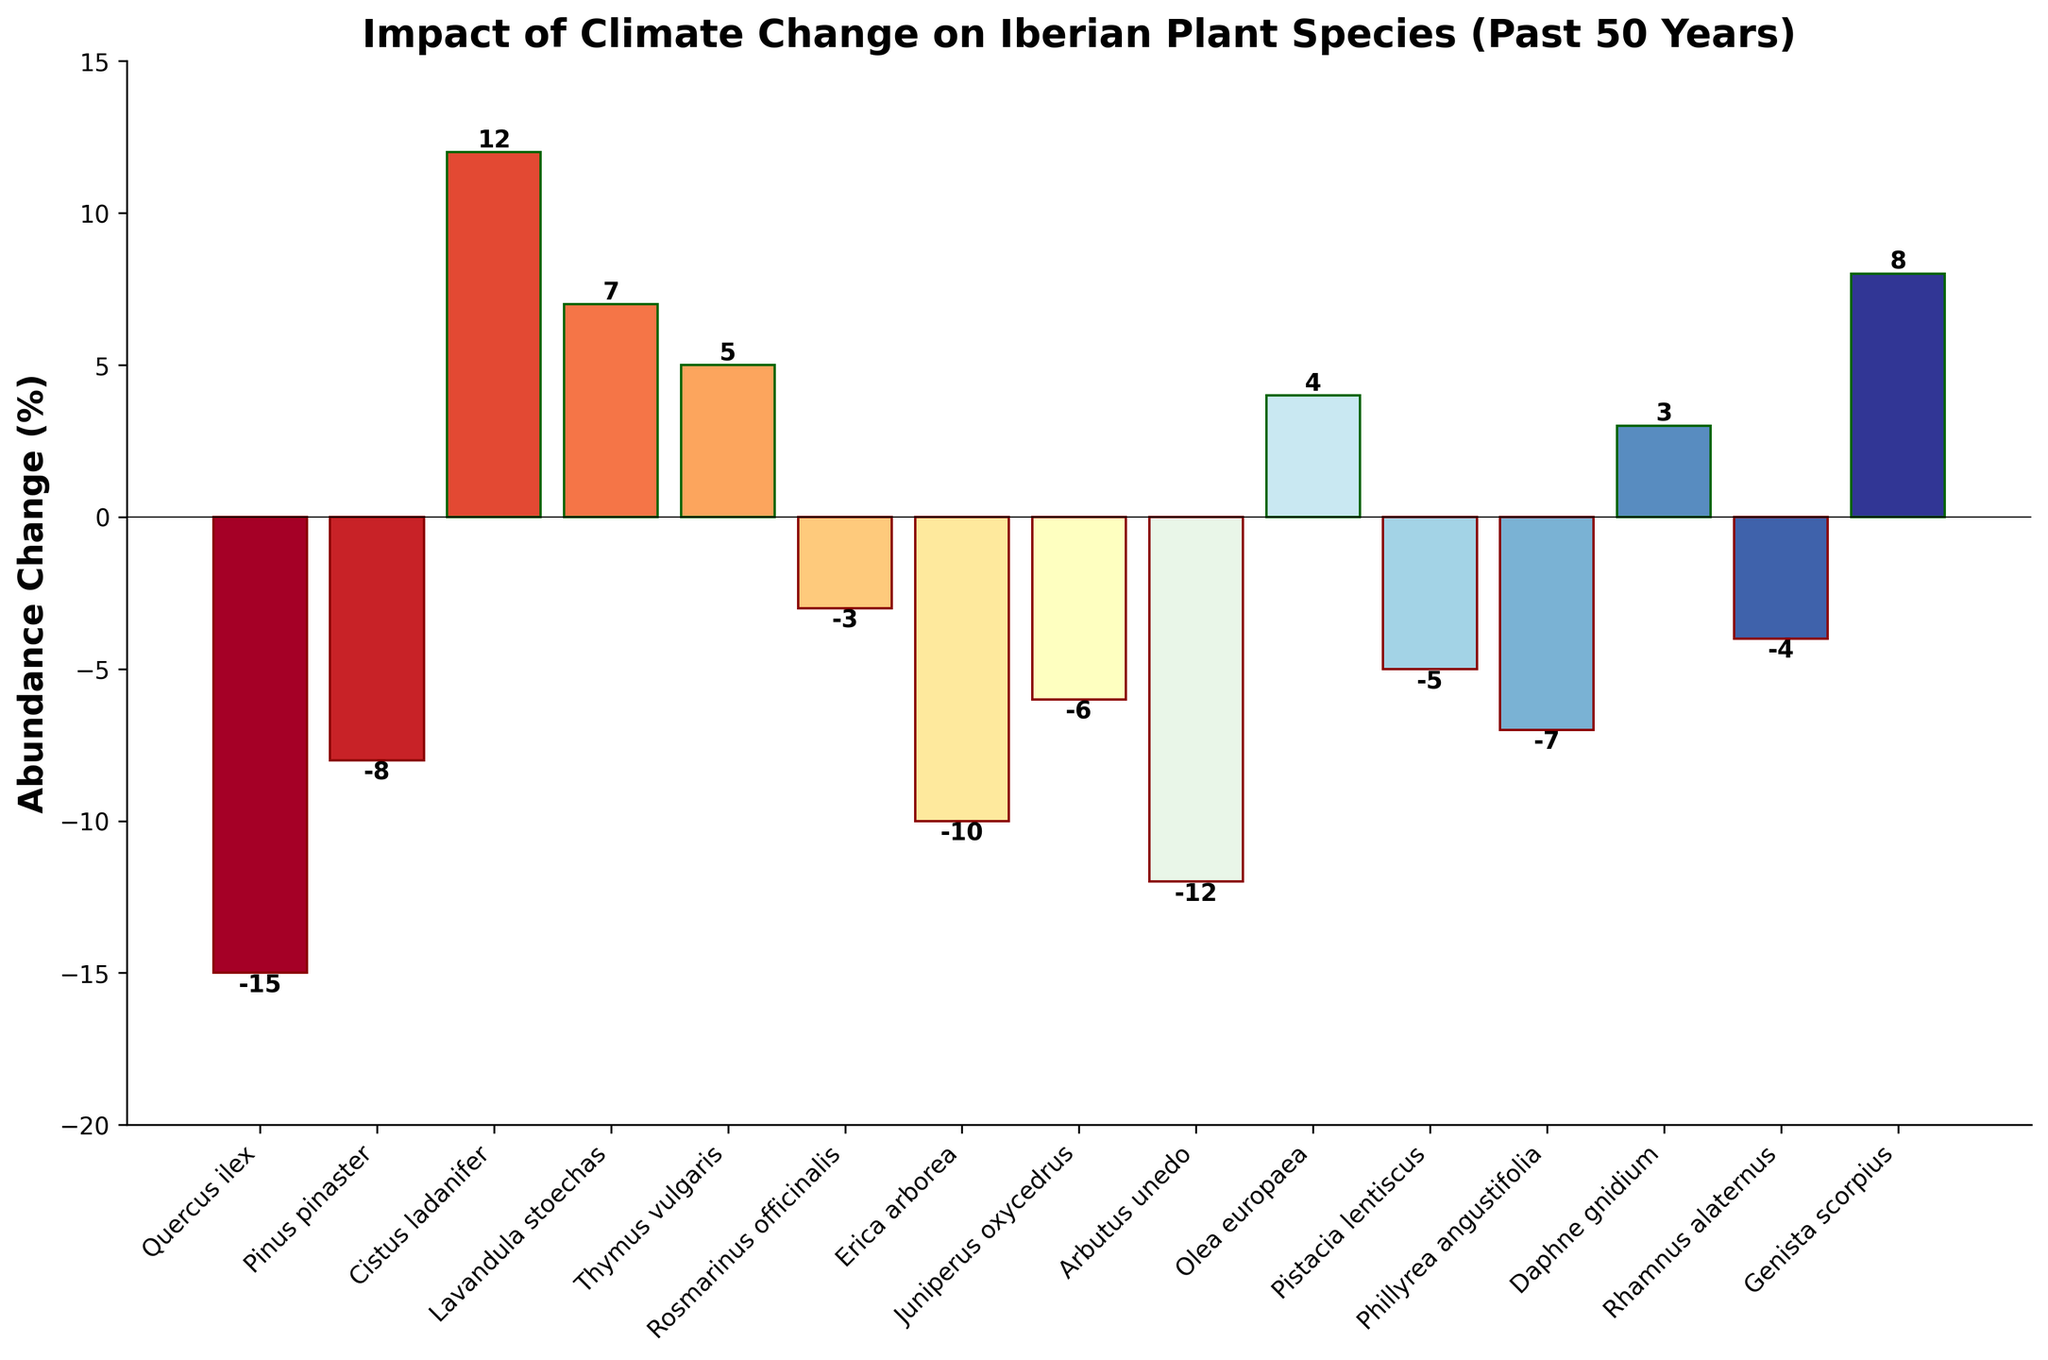What's the range of abundance change percentages for the displayed species? First, identify the maximum and minimum abundance change percentages from the figure. The maximum is 12% (Cistus ladanifer) and the minimum is -15% (Quercus ilex). Subtract the minimum from the maximum to obtain the range: 12 - (-15) = 27.
Answer: 27 Which species has shown the greatest decrease in abundance due to climate change? From the figure, identify the species with the most negative abundance change percentage. Quercus ilex has the most significant negative change of -15%, indicating the greatest decrease in abundance.
Answer: Quercus ilex Which species has the greatest positive abundance change and what is its value? Locate the species with the highest positive abundance change percentage in the figure. Cistus ladanifer has the highest positive change of 12%.
Answer: Cistus ladanifer, 12% Which two species have nearly equal abundance changes, and what are their values? Identify species with similar abundance change percentages by visually comparing the bar lengths. Rosmarinus officinalis (-3%) and Rhamnus alaternus (-4%) have nearly equal changes.
Answer: Rosmarinus officinalis (-3%) and Rhamnus alaternus (-4%) How many species have seen a decrease in their abundance? Count the number of bars that extend below the zero line (indicating a negative change) in the figure. A total of 8 species have experienced a decrease.
Answer: 8 What is the average abundance change for all species shown? Sum the abundance changes of all species and divide by the number of species. The sum is -15 + (-8) + 12 + 7 + 5 + (-3) + (-10) + (-6) + (-12) + 4 + (-5) + (-7) + 3 + (-4) + 8 = -31. There are 15 species, so the average is -31 / 15 ≈ -2.07.
Answer: -2.07 Is there a noticeable pattern in the abundance change among the different species? By examining the figure, we observe that most species have experienced a negative change in abundance. Specifically, 8 species show a decrease, while 7 species show an increase, indicating that more species are negatively impacted by climate change.
Answer: More species are negatively impacted 